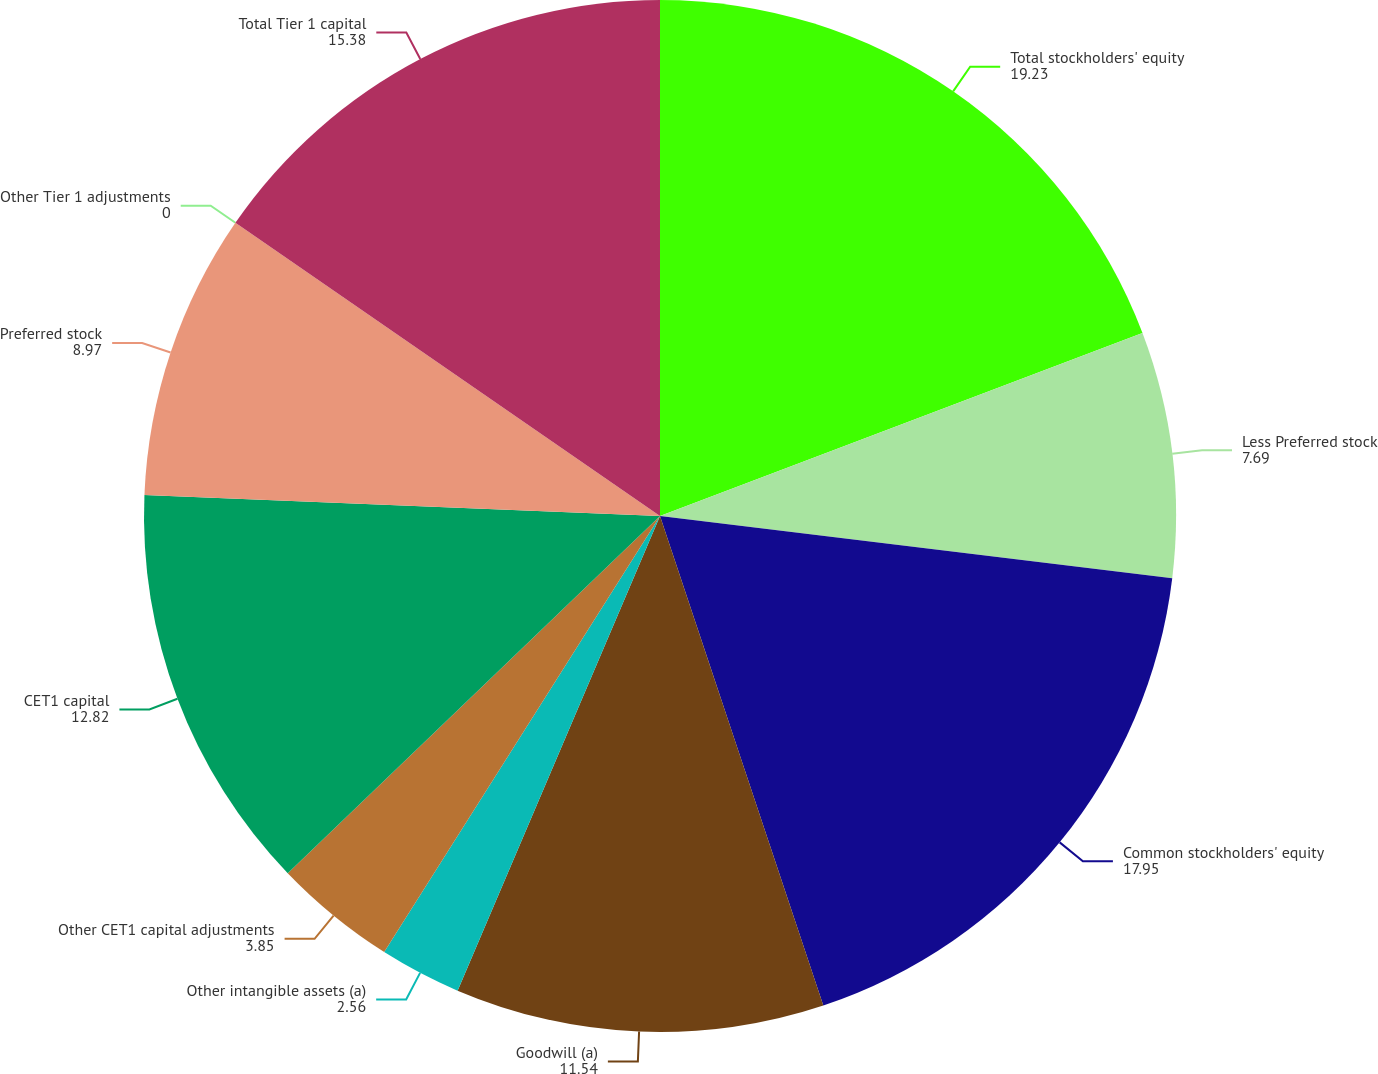<chart> <loc_0><loc_0><loc_500><loc_500><pie_chart><fcel>Total stockholders' equity<fcel>Less Preferred stock<fcel>Common stockholders' equity<fcel>Goodwill (a)<fcel>Other intangible assets (a)<fcel>Other CET1 capital adjustments<fcel>CET1 capital<fcel>Preferred stock<fcel>Other Tier 1 adjustments<fcel>Total Tier 1 capital<nl><fcel>19.23%<fcel>7.69%<fcel>17.95%<fcel>11.54%<fcel>2.56%<fcel>3.85%<fcel>12.82%<fcel>8.97%<fcel>0.0%<fcel>15.38%<nl></chart> 